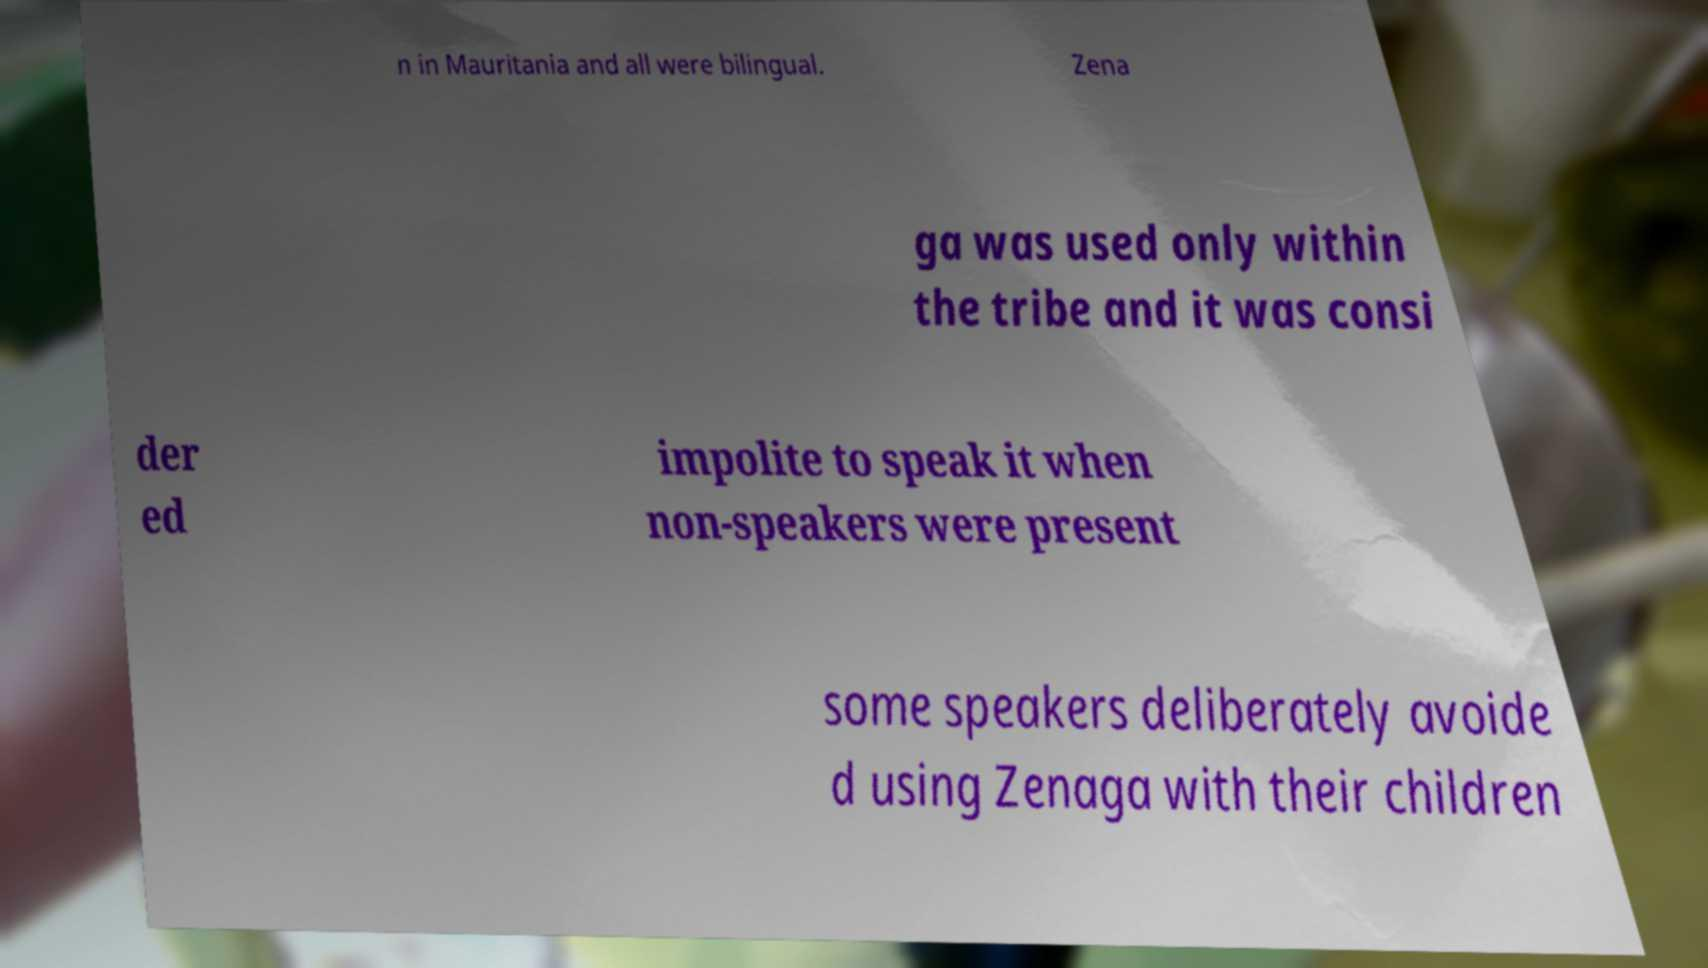Can you accurately transcribe the text from the provided image for me? n in Mauritania and all were bilingual. Zena ga was used only within the tribe and it was consi der ed impolite to speak it when non-speakers were present some speakers deliberately avoide d using Zenaga with their children 